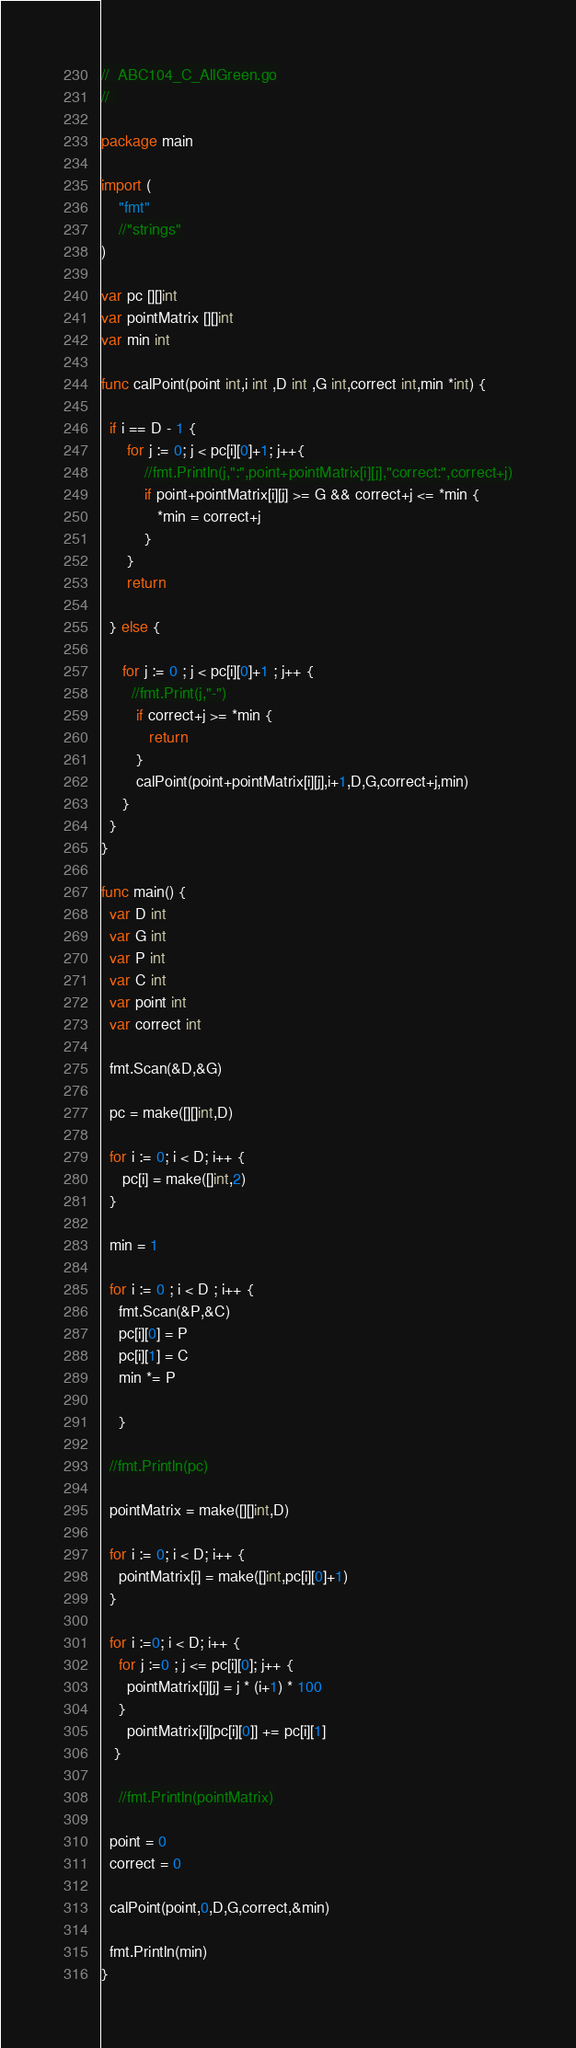Convert code to text. <code><loc_0><loc_0><loc_500><loc_500><_Go_>//  ABC104_C_AllGreen.go
// 

package main

import (
    "fmt"
    //"strings"
)

var pc [][]int
var pointMatrix [][]int
var min int

func calPoint(point int,i int ,D int ,G int,correct int,min *int) {

  if i == D - 1 {
      for j := 0; j < pc[i][0]+1; j++{
          //fmt.Println(j,":",point+pointMatrix[i][j],"correct:",correct+j)
          if point+pointMatrix[i][j] >= G && correct+j <= *min {
             *min = correct+j
          }
      }
      return

  } else {

     for j := 0 ; j < pc[i][0]+1 ; j++ {
       //fmt.Print(j,"-")
        if correct+j >= *min {
           return
        }
        calPoint(point+pointMatrix[i][j],i+1,D,G,correct+j,min)
     }
  }
}

func main() {
  var D int
  var G int
  var P int
  var C int
  var point int
  var correct int

  fmt.Scan(&D,&G)

  pc = make([][]int,D)

  for i := 0; i < D; i++ {
     pc[i] = make([]int,2)
  }

  min = 1

  for i := 0 ; i < D ; i++ {
    fmt.Scan(&P,&C)
    pc[i][0] = P
    pc[i][1] = C
    min *= P

    }

  //fmt.Println(pc)

  pointMatrix = make([][]int,D)

  for i := 0; i < D; i++ {
    pointMatrix[i] = make([]int,pc[i][0]+1)
  }

  for i :=0; i < D; i++ {
    for j :=0 ; j <= pc[i][0]; j++ {
      pointMatrix[i][j] = j * (i+1) * 100
    }
      pointMatrix[i][pc[i][0]] += pc[i][1]
   }

    //fmt.Println(pointMatrix)

  point = 0
  correct = 0

  calPoint(point,0,D,G,correct,&min)

  fmt.Println(min)
}


</code> 